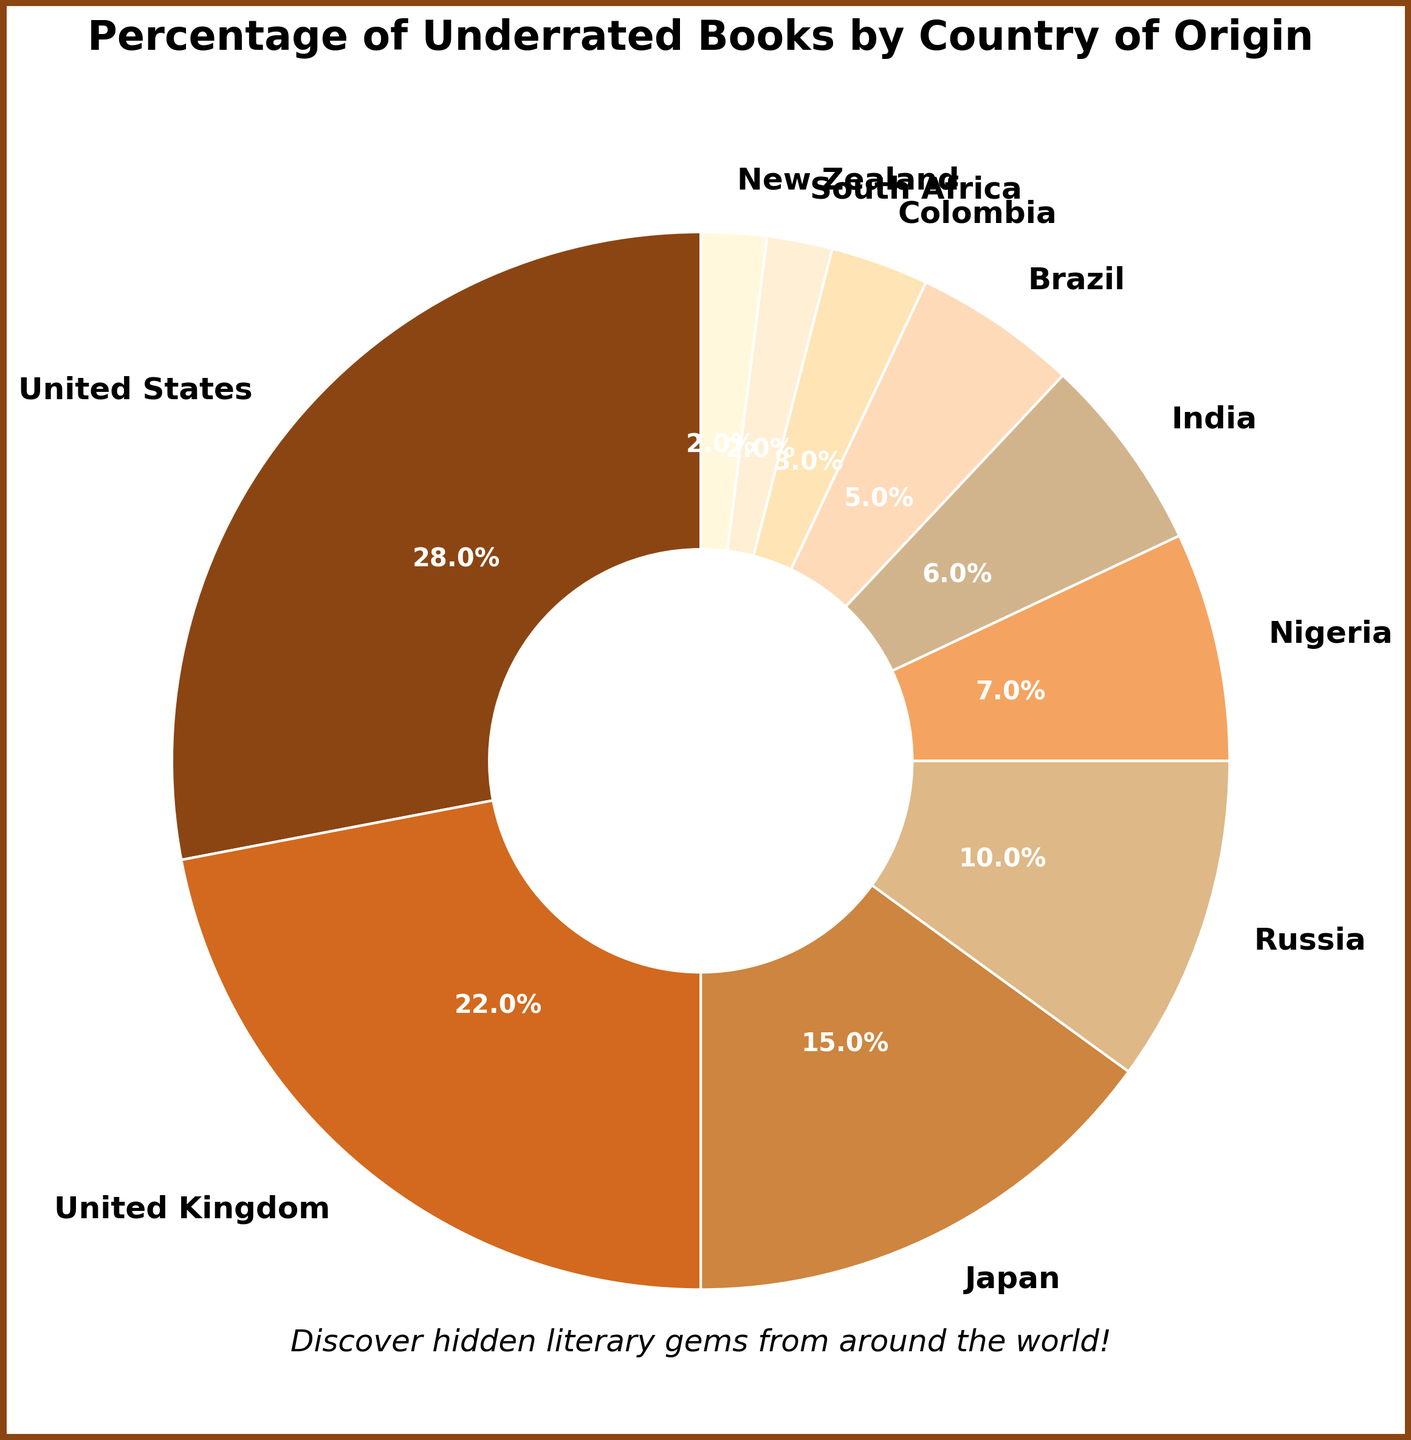Which country has the highest percentage of underrated books? The slice with the largest percentage shows it's the United States.
Answer: United States How many countries have a percentage of 10% or higher? By checking the slices, the United States, United Kingdom, and Japan have 10% or higher.
Answer: 3 Compare the percentages of Russia and Nigeria. Which is larger and by how much? Russia has 10% and Nigeria has 7%. The difference is 10% - 7% = 3%.
Answer: Russia by 3% What is the combined percentage of underrated books from South Africa and New Zealand? Adding the percentages for South Africa (2%) and New Zealand (2%) results in 2% + 2% = 4%.
Answer: 4% Identify the countries with the smallest percentages of underrated books and state those percentages. The slices with 2% each belong to South Africa and New Zealand.
Answer: South Africa and New Zealand, 2% each Which countries together make up exactly 50% of the underrated books? Adding the top five slices: United States (28%), United Kingdom (22%), Japan (15%), Russia (10%), and Nigeria (7%) sums to 28% + 22% + 15% + 10% + 7% = 82%. Adding Nigeria (7%) and India (6%) instead: 28% + 22% + 15% + 10% + 7% + 6% = 88%. Including Brazil (5%) instead of India leads to 83%. Continue fine-tuning with exact multiple possible countries. However, a combination of different smaller values likely not exact. More intricate than direct sum certain element.
Answer: Multiple combinations possible, more intricate without exact small multiple slices Identify the two lightest-colored slices and their associated countries. The lightest colors correspond to South Africa and New Zealand at 2% each.
Answer: South Africa and New Zealand 